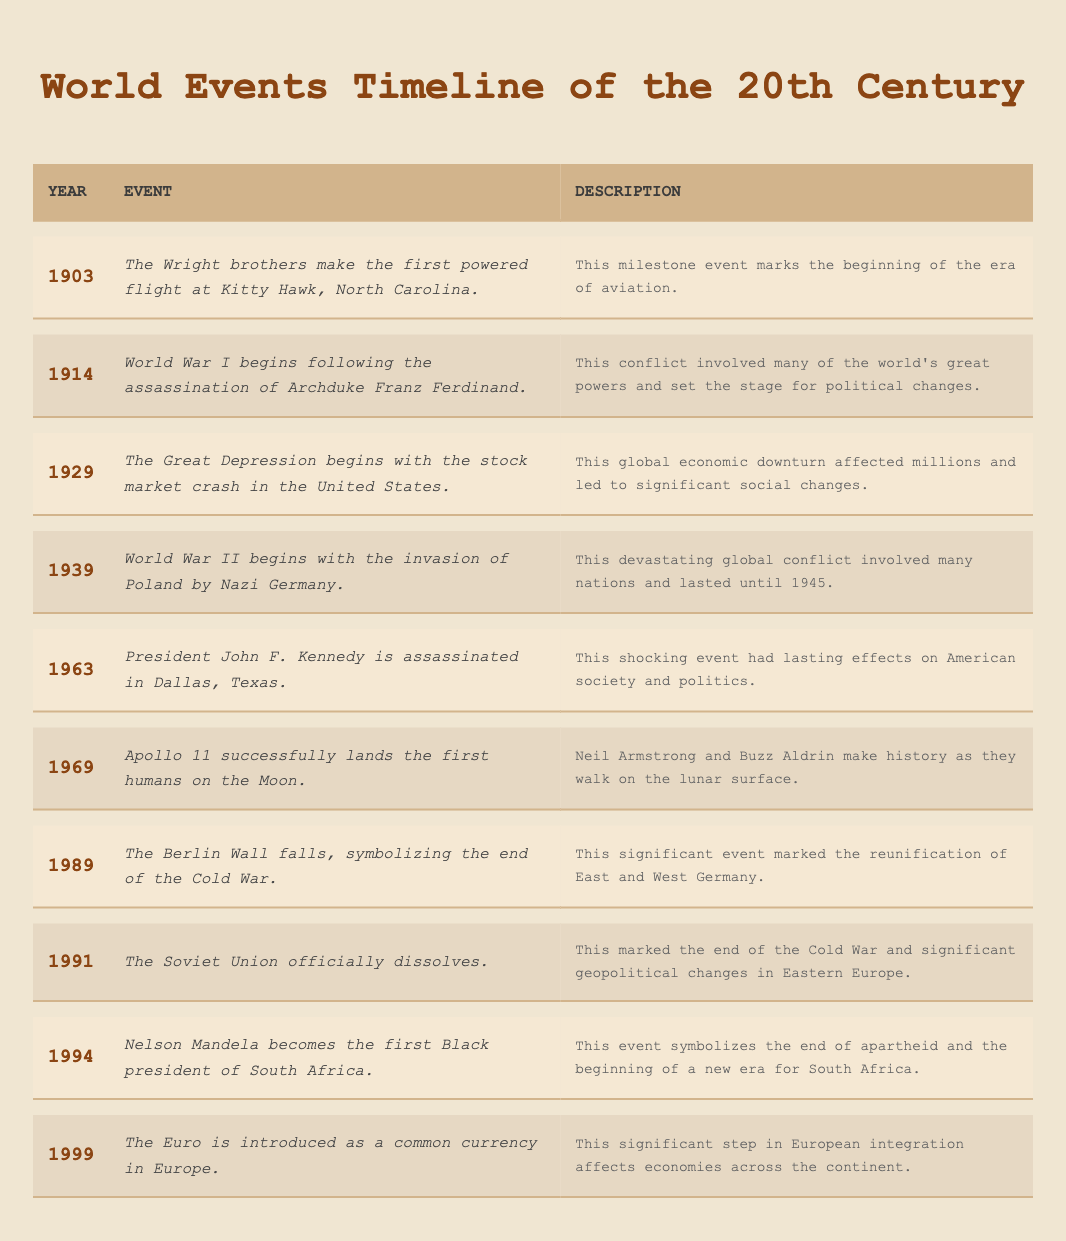What year did World War II begin? Referring to the table, World War II is noted to begin in the year 1939.
Answer: 1939 Which event marked the beginning of the Great Depression? The table indicates that the Great Depression began with the stock market crash in 1929.
Answer: Stock market crash in 1929 What was the significance of the Berlin Wall falling in 1989? According to the table, its fall symbolized the end of the Cold War and marked the reunification of East and West Germany.
Answer: End of the Cold War, reunification of Germany How many years passed between the first powered flight and the Moon landing? The first powered flight occurred in 1903 and the Moon landing in 1969. Calculating the difference: 1969 - 1903 = 66 years.
Answer: 66 years Did Nelson Mandela become president before or after the fall of the Berlin Wall? The table shows Mandela became president in 1994, while the Berlin Wall fell in 1989, indicating that Mandela became president after the Wall fell.
Answer: After What was the overall impact of the events listed between 1914 and 1945? The events between these years include World War I and World War II, both of which involved multiple great powers and had lasting political and social effects, including changes in borders and governance worldwide.
Answer: Lasting political and societal changes In what year did the Soviet Union dissolve, and what was its significance? The table states the Soviet Union dissolved in 1991, marking the end of the Cold War and significant political shifts in Eastern Europe.
Answer: 1991; end of the Cold War How many major wars are listed in the 20th-century timeline? The table lists two major wars: World War I (1914) and World War II (1939). So, there are a total of two major wars in this timeline.
Answer: 2 major wars What is the relationship between the introduction of the Euro and European integration? The table highlights the Euro's introduction in 1999 as a major step towards European integration, affecting economies across the continent.
Answer: Significant step in European integration Which event described in the table resulted in social changes within the United States? The assassination of President John F. Kennedy in 1963 is noted to have lasting effects on American society and politics, signaling profound social changes.
Answer: Kennedy's assassination in 1963 